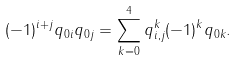Convert formula to latex. <formula><loc_0><loc_0><loc_500><loc_500>( - 1 ) ^ { i + j } q _ { 0 i } q _ { 0 j } & = \sum _ { k = 0 } ^ { 4 } q _ { i , j } ^ { k } ( - 1 ) ^ { k } q _ { 0 k } .</formula> 